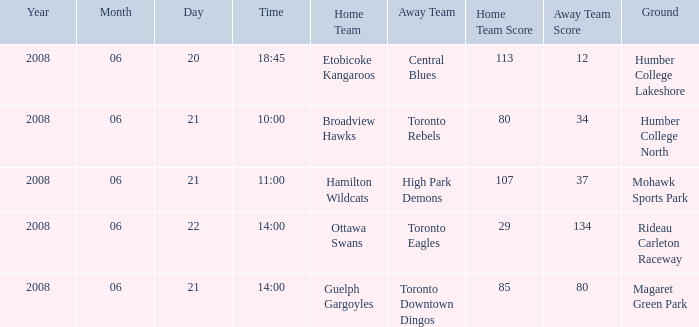What is the Away with a Ground that is humber college north? Toronto Rebels. 